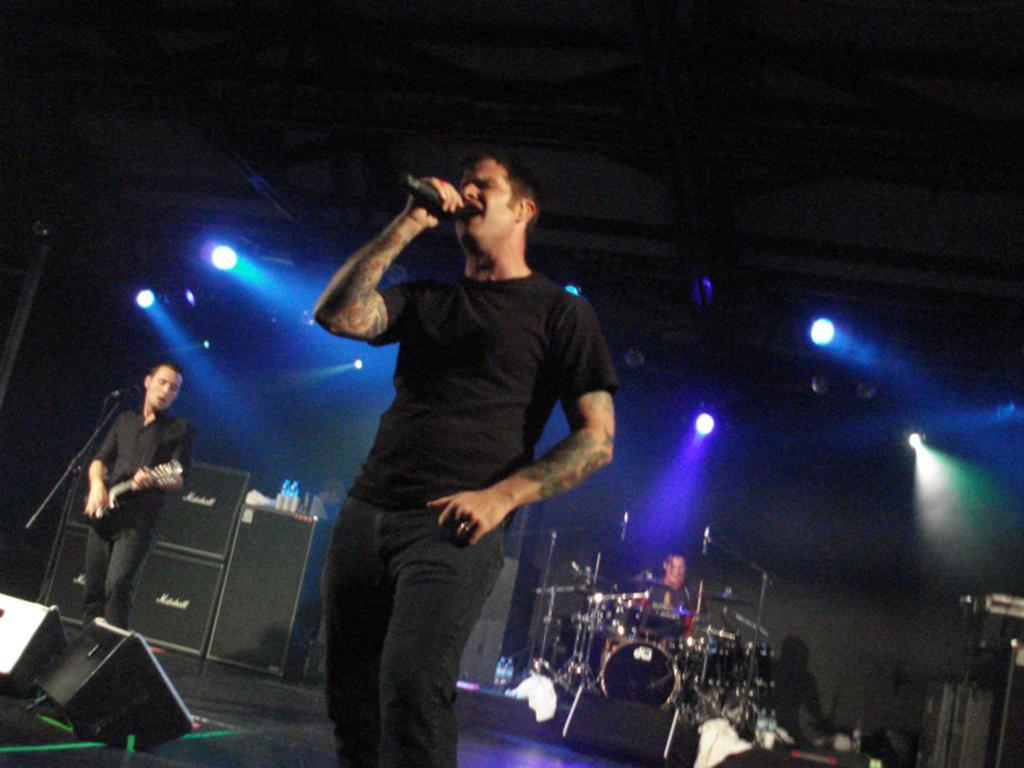In one or two sentences, can you explain what this image depicts? There are few people on the stage singing and performing by playing musical instruments behind them there are lights. 